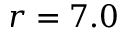Convert formula to latex. <formula><loc_0><loc_0><loc_500><loc_500>r = 7 . 0</formula> 